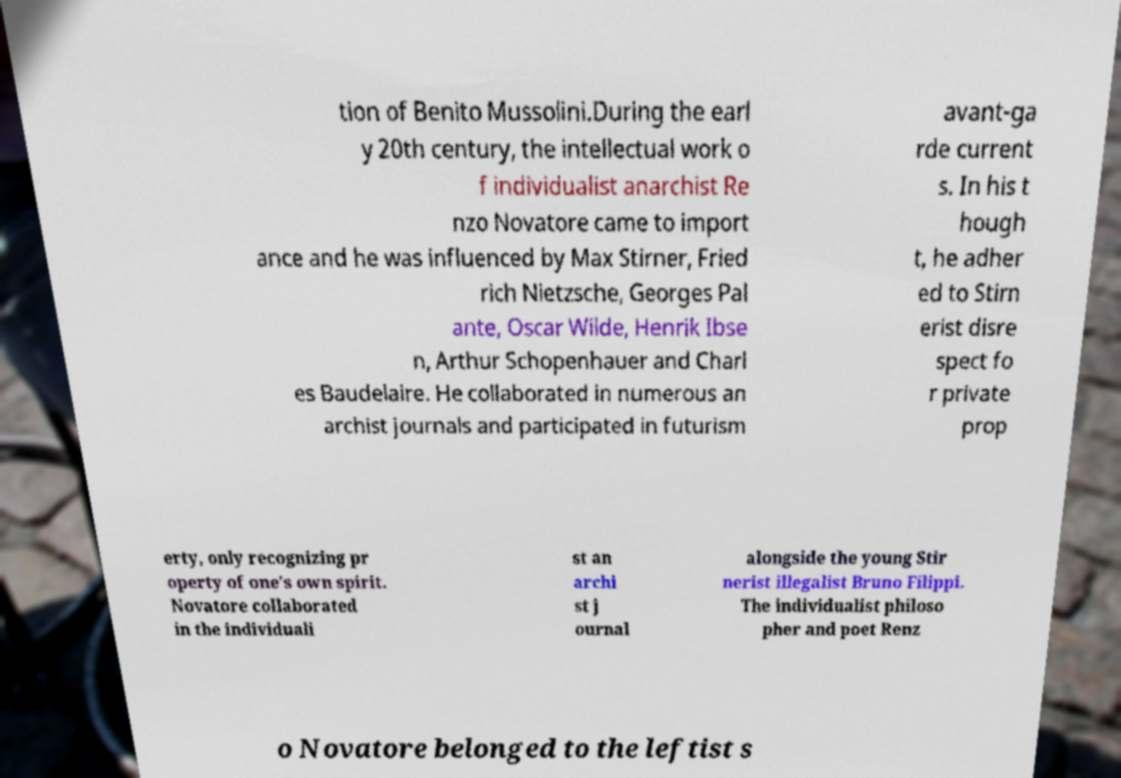Could you assist in decoding the text presented in this image and type it out clearly? tion of Benito Mussolini.During the earl y 20th century, the intellectual work o f individualist anarchist Re nzo Novatore came to import ance and he was influenced by Max Stirner, Fried rich Nietzsche, Georges Pal ante, Oscar Wilde, Henrik Ibse n, Arthur Schopenhauer and Charl es Baudelaire. He collaborated in numerous an archist journals and participated in futurism avant-ga rde current s. In his t hough t, he adher ed to Stirn erist disre spect fo r private prop erty, only recognizing pr operty of one's own spirit. Novatore collaborated in the individuali st an archi st j ournal alongside the young Stir nerist illegalist Bruno Filippi. The individualist philoso pher and poet Renz o Novatore belonged to the leftist s 